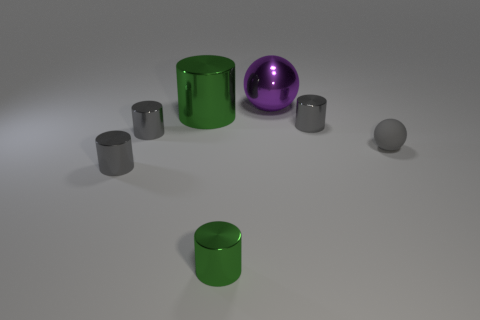There is a small gray object that is the same shape as the purple thing; what material is it?
Your answer should be very brief. Rubber. The big cylinder has what color?
Make the answer very short. Green. The metallic cylinder that is to the right of the green shiny cylinder that is in front of the tiny gray matte sphere is what color?
Provide a succinct answer. Gray. There is a large ball; is its color the same as the sphere that is in front of the large green metallic cylinder?
Your answer should be very brief. No. What number of shiny cylinders are behind the object that is in front of the small gray thing in front of the gray matte object?
Give a very brief answer. 4. Are there any big green metallic objects to the right of the small matte ball?
Offer a terse response. No. Are there any other things that are the same color as the metallic sphere?
Give a very brief answer. No. How many cubes are green metallic things or large shiny things?
Your answer should be compact. 0. What number of small metal objects are both in front of the tiny ball and behind the small green metallic object?
Offer a very short reply. 1. Are there the same number of tiny gray metal cylinders that are right of the small gray rubber thing and small cylinders behind the large purple metallic object?
Your response must be concise. Yes. 